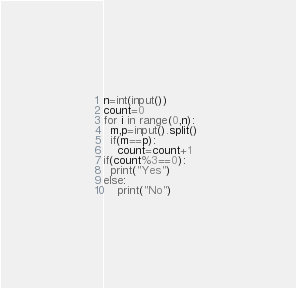<code> <loc_0><loc_0><loc_500><loc_500><_Python_>n=int(input())
count=0
for i in range(0,n):
  m,p=input().split() 
  if(m==p):
    count=count+1
if(count%3==0):
  print("Yes")
else:
    print("No")
</code> 